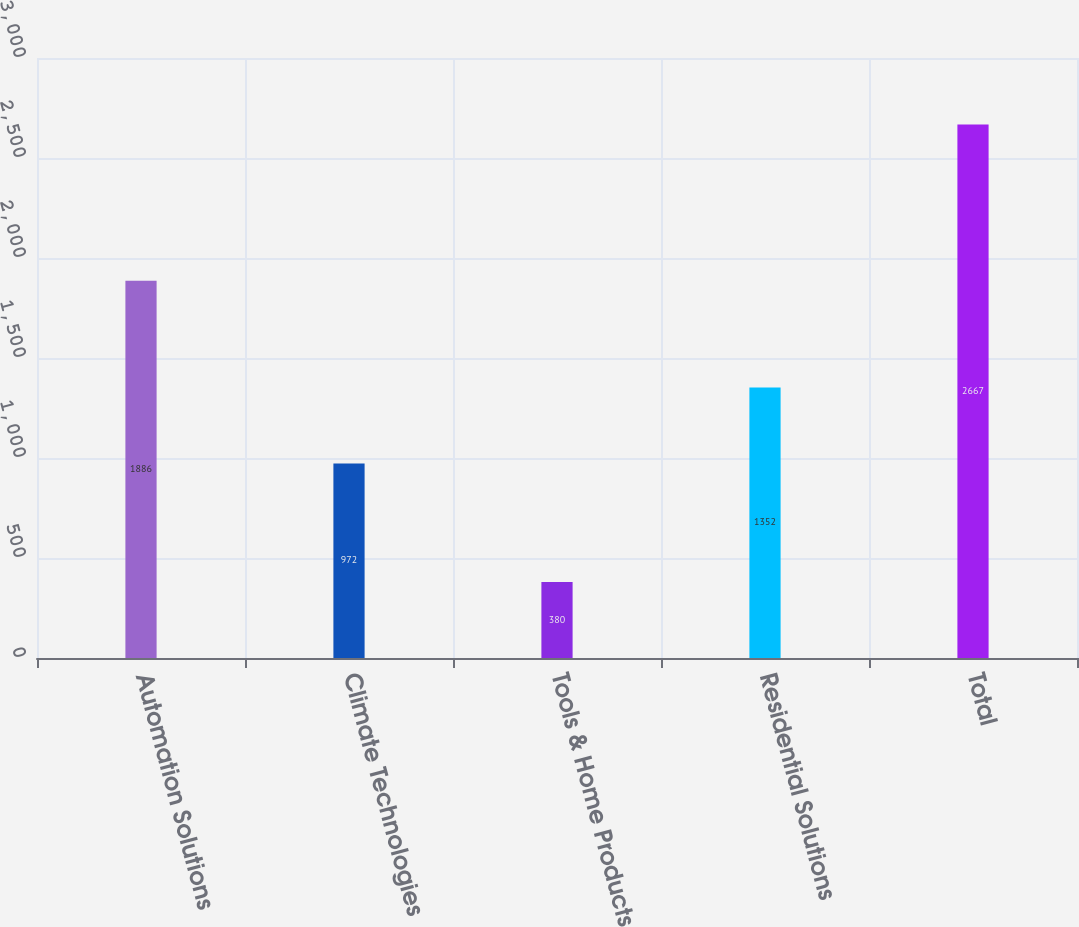Convert chart. <chart><loc_0><loc_0><loc_500><loc_500><bar_chart><fcel>Automation Solutions<fcel>Climate Technologies<fcel>Tools & Home Products<fcel>Residential Solutions<fcel>Total<nl><fcel>1886<fcel>972<fcel>380<fcel>1352<fcel>2667<nl></chart> 